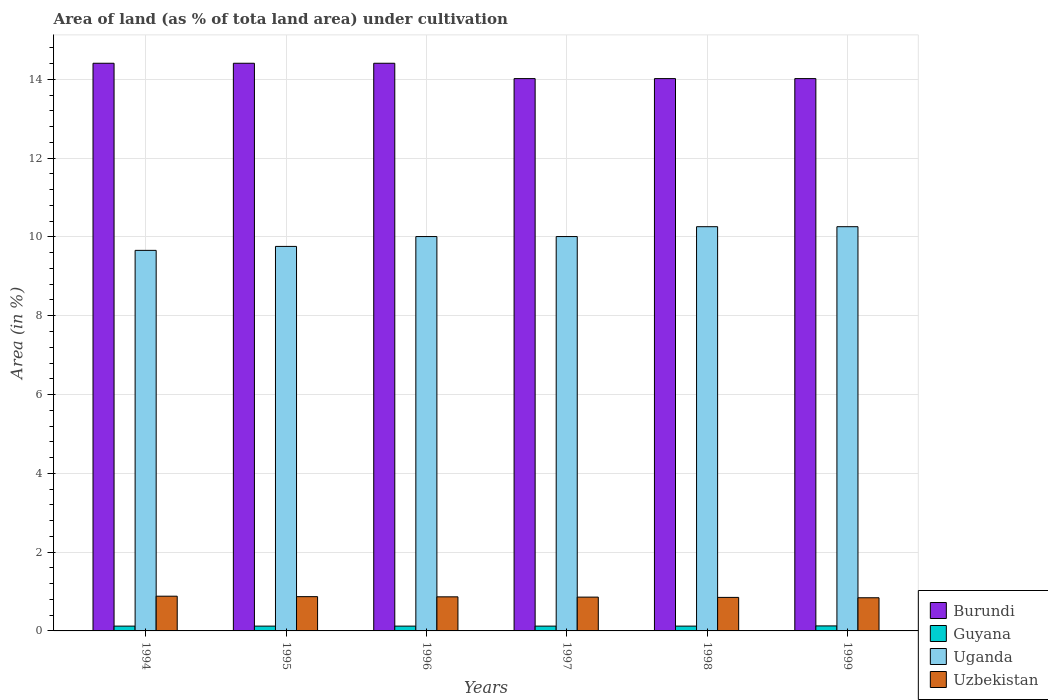Are the number of bars per tick equal to the number of legend labels?
Ensure brevity in your answer.  Yes. How many bars are there on the 4th tick from the left?
Provide a succinct answer. 4. What is the label of the 6th group of bars from the left?
Offer a very short reply. 1999. In how many cases, is the number of bars for a given year not equal to the number of legend labels?
Provide a short and direct response. 0. What is the percentage of land under cultivation in Guyana in 1994?
Make the answer very short. 0.12. Across all years, what is the maximum percentage of land under cultivation in Uganda?
Provide a succinct answer. 10.26. Across all years, what is the minimum percentage of land under cultivation in Burundi?
Offer a terse response. 14.02. In which year was the percentage of land under cultivation in Burundi maximum?
Offer a terse response. 1994. What is the total percentage of land under cultivation in Uzbekistan in the graph?
Keep it short and to the point. 5.17. What is the difference between the percentage of land under cultivation in Uzbekistan in 1997 and that in 1999?
Provide a succinct answer. 0.02. What is the difference between the percentage of land under cultivation in Uganda in 1994 and the percentage of land under cultivation in Guyana in 1995?
Your answer should be compact. 9.54. What is the average percentage of land under cultivation in Guyana per year?
Your response must be concise. 0.12. In the year 1998, what is the difference between the percentage of land under cultivation in Uzbekistan and percentage of land under cultivation in Guyana?
Your answer should be compact. 0.73. In how many years, is the percentage of land under cultivation in Uganda greater than 12 %?
Keep it short and to the point. 0. What is the ratio of the percentage of land under cultivation in Uzbekistan in 1997 to that in 1999?
Provide a short and direct response. 1.02. What is the difference between the highest and the lowest percentage of land under cultivation in Guyana?
Ensure brevity in your answer.  0.01. Is the sum of the percentage of land under cultivation in Uganda in 1995 and 1997 greater than the maximum percentage of land under cultivation in Burundi across all years?
Your answer should be compact. Yes. What does the 1st bar from the left in 1999 represents?
Keep it short and to the point. Burundi. What does the 2nd bar from the right in 1998 represents?
Keep it short and to the point. Uganda. Are all the bars in the graph horizontal?
Your answer should be very brief. No. How many years are there in the graph?
Keep it short and to the point. 6. Are the values on the major ticks of Y-axis written in scientific E-notation?
Provide a succinct answer. No. Does the graph contain any zero values?
Offer a very short reply. No. How are the legend labels stacked?
Provide a succinct answer. Vertical. What is the title of the graph?
Ensure brevity in your answer.  Area of land (as % of tota land area) under cultivation. Does "Canada" appear as one of the legend labels in the graph?
Offer a very short reply. No. What is the label or title of the Y-axis?
Provide a short and direct response. Area (in %). What is the Area (in %) of Burundi in 1994?
Make the answer very short. 14.41. What is the Area (in %) in Guyana in 1994?
Ensure brevity in your answer.  0.12. What is the Area (in %) in Uganda in 1994?
Keep it short and to the point. 9.66. What is the Area (in %) of Uzbekistan in 1994?
Offer a very short reply. 0.88. What is the Area (in %) in Burundi in 1995?
Ensure brevity in your answer.  14.41. What is the Area (in %) in Guyana in 1995?
Give a very brief answer. 0.12. What is the Area (in %) in Uganda in 1995?
Keep it short and to the point. 9.76. What is the Area (in %) of Uzbekistan in 1995?
Make the answer very short. 0.87. What is the Area (in %) in Burundi in 1996?
Your answer should be very brief. 14.41. What is the Area (in %) of Guyana in 1996?
Ensure brevity in your answer.  0.12. What is the Area (in %) of Uganda in 1996?
Your answer should be compact. 10.01. What is the Area (in %) in Uzbekistan in 1996?
Provide a short and direct response. 0.87. What is the Area (in %) in Burundi in 1997?
Ensure brevity in your answer.  14.02. What is the Area (in %) of Guyana in 1997?
Your answer should be compact. 0.12. What is the Area (in %) of Uganda in 1997?
Your answer should be compact. 10.01. What is the Area (in %) of Uzbekistan in 1997?
Offer a very short reply. 0.86. What is the Area (in %) of Burundi in 1998?
Your answer should be compact. 14.02. What is the Area (in %) in Guyana in 1998?
Ensure brevity in your answer.  0.12. What is the Area (in %) in Uganda in 1998?
Offer a terse response. 10.26. What is the Area (in %) in Uzbekistan in 1998?
Your answer should be compact. 0.85. What is the Area (in %) of Burundi in 1999?
Offer a very short reply. 14.02. What is the Area (in %) in Guyana in 1999?
Give a very brief answer. 0.13. What is the Area (in %) of Uganda in 1999?
Offer a very short reply. 10.26. What is the Area (in %) of Uzbekistan in 1999?
Keep it short and to the point. 0.84. Across all years, what is the maximum Area (in %) of Burundi?
Provide a succinct answer. 14.41. Across all years, what is the maximum Area (in %) of Guyana?
Your answer should be very brief. 0.13. Across all years, what is the maximum Area (in %) of Uganda?
Give a very brief answer. 10.26. Across all years, what is the maximum Area (in %) of Uzbekistan?
Your answer should be very brief. 0.88. Across all years, what is the minimum Area (in %) of Burundi?
Offer a very short reply. 14.02. Across all years, what is the minimum Area (in %) of Guyana?
Provide a succinct answer. 0.12. Across all years, what is the minimum Area (in %) in Uganda?
Your response must be concise. 9.66. Across all years, what is the minimum Area (in %) in Uzbekistan?
Provide a succinct answer. 0.84. What is the total Area (in %) in Burundi in the graph?
Keep it short and to the point. 85.28. What is the total Area (in %) in Guyana in the graph?
Offer a terse response. 0.74. What is the total Area (in %) of Uganda in the graph?
Provide a succinct answer. 59.96. What is the total Area (in %) in Uzbekistan in the graph?
Offer a terse response. 5.17. What is the difference between the Area (in %) of Guyana in 1994 and that in 1995?
Give a very brief answer. 0. What is the difference between the Area (in %) in Uganda in 1994 and that in 1995?
Keep it short and to the point. -0.1. What is the difference between the Area (in %) of Uzbekistan in 1994 and that in 1995?
Offer a very short reply. 0.01. What is the difference between the Area (in %) in Burundi in 1994 and that in 1996?
Offer a terse response. 0. What is the difference between the Area (in %) of Guyana in 1994 and that in 1996?
Provide a short and direct response. 0. What is the difference between the Area (in %) of Uganda in 1994 and that in 1996?
Your answer should be very brief. -0.35. What is the difference between the Area (in %) of Uzbekistan in 1994 and that in 1996?
Provide a short and direct response. 0.02. What is the difference between the Area (in %) in Burundi in 1994 and that in 1997?
Your answer should be very brief. 0.39. What is the difference between the Area (in %) in Guyana in 1994 and that in 1997?
Give a very brief answer. 0. What is the difference between the Area (in %) of Uganda in 1994 and that in 1997?
Your answer should be very brief. -0.35. What is the difference between the Area (in %) of Uzbekistan in 1994 and that in 1997?
Your answer should be compact. 0.02. What is the difference between the Area (in %) in Burundi in 1994 and that in 1998?
Give a very brief answer. 0.39. What is the difference between the Area (in %) of Uganda in 1994 and that in 1998?
Keep it short and to the point. -0.6. What is the difference between the Area (in %) of Uzbekistan in 1994 and that in 1998?
Your answer should be compact. 0.03. What is the difference between the Area (in %) in Burundi in 1994 and that in 1999?
Your answer should be very brief. 0.39. What is the difference between the Area (in %) of Guyana in 1994 and that in 1999?
Make the answer very short. -0.01. What is the difference between the Area (in %) in Uganda in 1994 and that in 1999?
Your answer should be compact. -0.6. What is the difference between the Area (in %) in Uzbekistan in 1994 and that in 1999?
Keep it short and to the point. 0.04. What is the difference between the Area (in %) in Burundi in 1995 and that in 1996?
Your response must be concise. 0. What is the difference between the Area (in %) of Uganda in 1995 and that in 1996?
Keep it short and to the point. -0.25. What is the difference between the Area (in %) in Uzbekistan in 1995 and that in 1996?
Your answer should be compact. 0. What is the difference between the Area (in %) of Burundi in 1995 and that in 1997?
Provide a succinct answer. 0.39. What is the difference between the Area (in %) in Guyana in 1995 and that in 1997?
Give a very brief answer. 0. What is the difference between the Area (in %) of Uganda in 1995 and that in 1997?
Provide a succinct answer. -0.25. What is the difference between the Area (in %) in Uzbekistan in 1995 and that in 1997?
Provide a short and direct response. 0.01. What is the difference between the Area (in %) in Burundi in 1995 and that in 1998?
Ensure brevity in your answer.  0.39. What is the difference between the Area (in %) in Uganda in 1995 and that in 1998?
Make the answer very short. -0.5. What is the difference between the Area (in %) of Uzbekistan in 1995 and that in 1998?
Your answer should be very brief. 0.02. What is the difference between the Area (in %) in Burundi in 1995 and that in 1999?
Offer a very short reply. 0.39. What is the difference between the Area (in %) of Guyana in 1995 and that in 1999?
Your response must be concise. -0.01. What is the difference between the Area (in %) in Uganda in 1995 and that in 1999?
Keep it short and to the point. -0.5. What is the difference between the Area (in %) in Uzbekistan in 1995 and that in 1999?
Make the answer very short. 0.03. What is the difference between the Area (in %) of Burundi in 1996 and that in 1997?
Ensure brevity in your answer.  0.39. What is the difference between the Area (in %) in Uganda in 1996 and that in 1997?
Offer a very short reply. 0. What is the difference between the Area (in %) of Uzbekistan in 1996 and that in 1997?
Ensure brevity in your answer.  0.01. What is the difference between the Area (in %) in Burundi in 1996 and that in 1998?
Provide a succinct answer. 0.39. What is the difference between the Area (in %) in Guyana in 1996 and that in 1998?
Your answer should be compact. 0. What is the difference between the Area (in %) in Uganda in 1996 and that in 1998?
Ensure brevity in your answer.  -0.25. What is the difference between the Area (in %) of Uzbekistan in 1996 and that in 1998?
Offer a terse response. 0.01. What is the difference between the Area (in %) of Burundi in 1996 and that in 1999?
Offer a very short reply. 0.39. What is the difference between the Area (in %) in Guyana in 1996 and that in 1999?
Offer a terse response. -0.01. What is the difference between the Area (in %) of Uganda in 1996 and that in 1999?
Make the answer very short. -0.25. What is the difference between the Area (in %) of Uzbekistan in 1996 and that in 1999?
Offer a terse response. 0.02. What is the difference between the Area (in %) in Guyana in 1997 and that in 1998?
Give a very brief answer. 0. What is the difference between the Area (in %) of Uganda in 1997 and that in 1998?
Your answer should be compact. -0.25. What is the difference between the Area (in %) of Uzbekistan in 1997 and that in 1998?
Ensure brevity in your answer.  0.01. What is the difference between the Area (in %) of Burundi in 1997 and that in 1999?
Make the answer very short. 0. What is the difference between the Area (in %) in Guyana in 1997 and that in 1999?
Provide a short and direct response. -0.01. What is the difference between the Area (in %) in Uganda in 1997 and that in 1999?
Your answer should be very brief. -0.25. What is the difference between the Area (in %) in Uzbekistan in 1997 and that in 1999?
Ensure brevity in your answer.  0.02. What is the difference between the Area (in %) of Guyana in 1998 and that in 1999?
Make the answer very short. -0.01. What is the difference between the Area (in %) of Uzbekistan in 1998 and that in 1999?
Offer a very short reply. 0.01. What is the difference between the Area (in %) of Burundi in 1994 and the Area (in %) of Guyana in 1995?
Give a very brief answer. 14.29. What is the difference between the Area (in %) in Burundi in 1994 and the Area (in %) in Uganda in 1995?
Provide a succinct answer. 4.65. What is the difference between the Area (in %) in Burundi in 1994 and the Area (in %) in Uzbekistan in 1995?
Offer a terse response. 13.54. What is the difference between the Area (in %) of Guyana in 1994 and the Area (in %) of Uganda in 1995?
Keep it short and to the point. -9.64. What is the difference between the Area (in %) in Guyana in 1994 and the Area (in %) in Uzbekistan in 1995?
Give a very brief answer. -0.75. What is the difference between the Area (in %) in Uganda in 1994 and the Area (in %) in Uzbekistan in 1995?
Keep it short and to the point. 8.79. What is the difference between the Area (in %) of Burundi in 1994 and the Area (in %) of Guyana in 1996?
Provide a succinct answer. 14.29. What is the difference between the Area (in %) of Burundi in 1994 and the Area (in %) of Uganda in 1996?
Provide a succinct answer. 4.4. What is the difference between the Area (in %) in Burundi in 1994 and the Area (in %) in Uzbekistan in 1996?
Give a very brief answer. 13.54. What is the difference between the Area (in %) of Guyana in 1994 and the Area (in %) of Uganda in 1996?
Ensure brevity in your answer.  -9.89. What is the difference between the Area (in %) in Guyana in 1994 and the Area (in %) in Uzbekistan in 1996?
Offer a very short reply. -0.74. What is the difference between the Area (in %) of Uganda in 1994 and the Area (in %) of Uzbekistan in 1996?
Give a very brief answer. 8.79. What is the difference between the Area (in %) of Burundi in 1994 and the Area (in %) of Guyana in 1997?
Your answer should be compact. 14.29. What is the difference between the Area (in %) in Burundi in 1994 and the Area (in %) in Uganda in 1997?
Your answer should be very brief. 4.4. What is the difference between the Area (in %) of Burundi in 1994 and the Area (in %) of Uzbekistan in 1997?
Provide a short and direct response. 13.55. What is the difference between the Area (in %) of Guyana in 1994 and the Area (in %) of Uganda in 1997?
Make the answer very short. -9.89. What is the difference between the Area (in %) of Guyana in 1994 and the Area (in %) of Uzbekistan in 1997?
Provide a succinct answer. -0.74. What is the difference between the Area (in %) of Uganda in 1994 and the Area (in %) of Uzbekistan in 1997?
Your answer should be compact. 8.8. What is the difference between the Area (in %) of Burundi in 1994 and the Area (in %) of Guyana in 1998?
Give a very brief answer. 14.29. What is the difference between the Area (in %) in Burundi in 1994 and the Area (in %) in Uganda in 1998?
Keep it short and to the point. 4.15. What is the difference between the Area (in %) in Burundi in 1994 and the Area (in %) in Uzbekistan in 1998?
Your answer should be very brief. 13.56. What is the difference between the Area (in %) of Guyana in 1994 and the Area (in %) of Uganda in 1998?
Ensure brevity in your answer.  -10.14. What is the difference between the Area (in %) in Guyana in 1994 and the Area (in %) in Uzbekistan in 1998?
Your response must be concise. -0.73. What is the difference between the Area (in %) in Uganda in 1994 and the Area (in %) in Uzbekistan in 1998?
Provide a succinct answer. 8.81. What is the difference between the Area (in %) in Burundi in 1994 and the Area (in %) in Guyana in 1999?
Your response must be concise. 14.28. What is the difference between the Area (in %) of Burundi in 1994 and the Area (in %) of Uganda in 1999?
Give a very brief answer. 4.15. What is the difference between the Area (in %) in Burundi in 1994 and the Area (in %) in Uzbekistan in 1999?
Provide a short and direct response. 13.57. What is the difference between the Area (in %) in Guyana in 1994 and the Area (in %) in Uganda in 1999?
Provide a short and direct response. -10.14. What is the difference between the Area (in %) in Guyana in 1994 and the Area (in %) in Uzbekistan in 1999?
Keep it short and to the point. -0.72. What is the difference between the Area (in %) in Uganda in 1994 and the Area (in %) in Uzbekistan in 1999?
Give a very brief answer. 8.82. What is the difference between the Area (in %) in Burundi in 1995 and the Area (in %) in Guyana in 1996?
Ensure brevity in your answer.  14.29. What is the difference between the Area (in %) of Burundi in 1995 and the Area (in %) of Uganda in 1996?
Ensure brevity in your answer.  4.4. What is the difference between the Area (in %) in Burundi in 1995 and the Area (in %) in Uzbekistan in 1996?
Offer a very short reply. 13.54. What is the difference between the Area (in %) in Guyana in 1995 and the Area (in %) in Uganda in 1996?
Your answer should be compact. -9.89. What is the difference between the Area (in %) of Guyana in 1995 and the Area (in %) of Uzbekistan in 1996?
Offer a very short reply. -0.74. What is the difference between the Area (in %) in Uganda in 1995 and the Area (in %) in Uzbekistan in 1996?
Your response must be concise. 8.89. What is the difference between the Area (in %) in Burundi in 1995 and the Area (in %) in Guyana in 1997?
Give a very brief answer. 14.29. What is the difference between the Area (in %) in Burundi in 1995 and the Area (in %) in Uganda in 1997?
Your answer should be very brief. 4.4. What is the difference between the Area (in %) of Burundi in 1995 and the Area (in %) of Uzbekistan in 1997?
Offer a very short reply. 13.55. What is the difference between the Area (in %) of Guyana in 1995 and the Area (in %) of Uganda in 1997?
Your answer should be very brief. -9.89. What is the difference between the Area (in %) of Guyana in 1995 and the Area (in %) of Uzbekistan in 1997?
Offer a very short reply. -0.74. What is the difference between the Area (in %) in Uganda in 1995 and the Area (in %) in Uzbekistan in 1997?
Your response must be concise. 8.9. What is the difference between the Area (in %) in Burundi in 1995 and the Area (in %) in Guyana in 1998?
Provide a succinct answer. 14.29. What is the difference between the Area (in %) of Burundi in 1995 and the Area (in %) of Uganda in 1998?
Provide a succinct answer. 4.15. What is the difference between the Area (in %) in Burundi in 1995 and the Area (in %) in Uzbekistan in 1998?
Give a very brief answer. 13.56. What is the difference between the Area (in %) of Guyana in 1995 and the Area (in %) of Uganda in 1998?
Provide a short and direct response. -10.14. What is the difference between the Area (in %) of Guyana in 1995 and the Area (in %) of Uzbekistan in 1998?
Your response must be concise. -0.73. What is the difference between the Area (in %) in Uganda in 1995 and the Area (in %) in Uzbekistan in 1998?
Your answer should be very brief. 8.91. What is the difference between the Area (in %) of Burundi in 1995 and the Area (in %) of Guyana in 1999?
Your answer should be very brief. 14.28. What is the difference between the Area (in %) of Burundi in 1995 and the Area (in %) of Uganda in 1999?
Your answer should be very brief. 4.15. What is the difference between the Area (in %) in Burundi in 1995 and the Area (in %) in Uzbekistan in 1999?
Make the answer very short. 13.57. What is the difference between the Area (in %) of Guyana in 1995 and the Area (in %) of Uganda in 1999?
Give a very brief answer. -10.14. What is the difference between the Area (in %) in Guyana in 1995 and the Area (in %) in Uzbekistan in 1999?
Provide a succinct answer. -0.72. What is the difference between the Area (in %) in Uganda in 1995 and the Area (in %) in Uzbekistan in 1999?
Provide a succinct answer. 8.92. What is the difference between the Area (in %) of Burundi in 1996 and the Area (in %) of Guyana in 1997?
Offer a very short reply. 14.29. What is the difference between the Area (in %) of Burundi in 1996 and the Area (in %) of Uganda in 1997?
Your answer should be compact. 4.4. What is the difference between the Area (in %) in Burundi in 1996 and the Area (in %) in Uzbekistan in 1997?
Make the answer very short. 13.55. What is the difference between the Area (in %) of Guyana in 1996 and the Area (in %) of Uganda in 1997?
Provide a succinct answer. -9.89. What is the difference between the Area (in %) of Guyana in 1996 and the Area (in %) of Uzbekistan in 1997?
Provide a succinct answer. -0.74. What is the difference between the Area (in %) in Uganda in 1996 and the Area (in %) in Uzbekistan in 1997?
Give a very brief answer. 9.15. What is the difference between the Area (in %) in Burundi in 1996 and the Area (in %) in Guyana in 1998?
Provide a short and direct response. 14.29. What is the difference between the Area (in %) of Burundi in 1996 and the Area (in %) of Uganda in 1998?
Ensure brevity in your answer.  4.15. What is the difference between the Area (in %) of Burundi in 1996 and the Area (in %) of Uzbekistan in 1998?
Keep it short and to the point. 13.56. What is the difference between the Area (in %) in Guyana in 1996 and the Area (in %) in Uganda in 1998?
Provide a succinct answer. -10.14. What is the difference between the Area (in %) of Guyana in 1996 and the Area (in %) of Uzbekistan in 1998?
Your answer should be very brief. -0.73. What is the difference between the Area (in %) of Uganda in 1996 and the Area (in %) of Uzbekistan in 1998?
Make the answer very short. 9.16. What is the difference between the Area (in %) of Burundi in 1996 and the Area (in %) of Guyana in 1999?
Keep it short and to the point. 14.28. What is the difference between the Area (in %) in Burundi in 1996 and the Area (in %) in Uganda in 1999?
Give a very brief answer. 4.15. What is the difference between the Area (in %) in Burundi in 1996 and the Area (in %) in Uzbekistan in 1999?
Your response must be concise. 13.57. What is the difference between the Area (in %) of Guyana in 1996 and the Area (in %) of Uganda in 1999?
Ensure brevity in your answer.  -10.14. What is the difference between the Area (in %) of Guyana in 1996 and the Area (in %) of Uzbekistan in 1999?
Your answer should be compact. -0.72. What is the difference between the Area (in %) in Uganda in 1996 and the Area (in %) in Uzbekistan in 1999?
Offer a terse response. 9.17. What is the difference between the Area (in %) of Burundi in 1997 and the Area (in %) of Guyana in 1998?
Your answer should be very brief. 13.9. What is the difference between the Area (in %) in Burundi in 1997 and the Area (in %) in Uganda in 1998?
Your response must be concise. 3.76. What is the difference between the Area (in %) of Burundi in 1997 and the Area (in %) of Uzbekistan in 1998?
Offer a very short reply. 13.17. What is the difference between the Area (in %) in Guyana in 1997 and the Area (in %) in Uganda in 1998?
Make the answer very short. -10.14. What is the difference between the Area (in %) in Guyana in 1997 and the Area (in %) in Uzbekistan in 1998?
Your response must be concise. -0.73. What is the difference between the Area (in %) of Uganda in 1997 and the Area (in %) of Uzbekistan in 1998?
Provide a succinct answer. 9.16. What is the difference between the Area (in %) in Burundi in 1997 and the Area (in %) in Guyana in 1999?
Make the answer very short. 13.89. What is the difference between the Area (in %) in Burundi in 1997 and the Area (in %) in Uganda in 1999?
Offer a very short reply. 3.76. What is the difference between the Area (in %) of Burundi in 1997 and the Area (in %) of Uzbekistan in 1999?
Give a very brief answer. 13.18. What is the difference between the Area (in %) of Guyana in 1997 and the Area (in %) of Uganda in 1999?
Your response must be concise. -10.14. What is the difference between the Area (in %) of Guyana in 1997 and the Area (in %) of Uzbekistan in 1999?
Keep it short and to the point. -0.72. What is the difference between the Area (in %) of Uganda in 1997 and the Area (in %) of Uzbekistan in 1999?
Provide a short and direct response. 9.17. What is the difference between the Area (in %) in Burundi in 1998 and the Area (in %) in Guyana in 1999?
Make the answer very short. 13.89. What is the difference between the Area (in %) in Burundi in 1998 and the Area (in %) in Uganda in 1999?
Your answer should be compact. 3.76. What is the difference between the Area (in %) in Burundi in 1998 and the Area (in %) in Uzbekistan in 1999?
Your response must be concise. 13.18. What is the difference between the Area (in %) of Guyana in 1998 and the Area (in %) of Uganda in 1999?
Keep it short and to the point. -10.14. What is the difference between the Area (in %) of Guyana in 1998 and the Area (in %) of Uzbekistan in 1999?
Your response must be concise. -0.72. What is the difference between the Area (in %) in Uganda in 1998 and the Area (in %) in Uzbekistan in 1999?
Your response must be concise. 9.42. What is the average Area (in %) in Burundi per year?
Make the answer very short. 14.21. What is the average Area (in %) in Guyana per year?
Provide a short and direct response. 0.12. What is the average Area (in %) in Uganda per year?
Offer a terse response. 9.99. What is the average Area (in %) of Uzbekistan per year?
Give a very brief answer. 0.86. In the year 1994, what is the difference between the Area (in %) in Burundi and Area (in %) in Guyana?
Keep it short and to the point. 14.29. In the year 1994, what is the difference between the Area (in %) of Burundi and Area (in %) of Uganda?
Your answer should be compact. 4.75. In the year 1994, what is the difference between the Area (in %) of Burundi and Area (in %) of Uzbekistan?
Keep it short and to the point. 13.53. In the year 1994, what is the difference between the Area (in %) in Guyana and Area (in %) in Uganda?
Ensure brevity in your answer.  -9.54. In the year 1994, what is the difference between the Area (in %) of Guyana and Area (in %) of Uzbekistan?
Keep it short and to the point. -0.76. In the year 1994, what is the difference between the Area (in %) in Uganda and Area (in %) in Uzbekistan?
Your answer should be very brief. 8.78. In the year 1995, what is the difference between the Area (in %) in Burundi and Area (in %) in Guyana?
Ensure brevity in your answer.  14.29. In the year 1995, what is the difference between the Area (in %) of Burundi and Area (in %) of Uganda?
Your answer should be compact. 4.65. In the year 1995, what is the difference between the Area (in %) of Burundi and Area (in %) of Uzbekistan?
Keep it short and to the point. 13.54. In the year 1995, what is the difference between the Area (in %) of Guyana and Area (in %) of Uganda?
Ensure brevity in your answer.  -9.64. In the year 1995, what is the difference between the Area (in %) of Guyana and Area (in %) of Uzbekistan?
Your answer should be compact. -0.75. In the year 1995, what is the difference between the Area (in %) of Uganda and Area (in %) of Uzbekistan?
Keep it short and to the point. 8.89. In the year 1996, what is the difference between the Area (in %) of Burundi and Area (in %) of Guyana?
Your response must be concise. 14.29. In the year 1996, what is the difference between the Area (in %) of Burundi and Area (in %) of Uganda?
Offer a terse response. 4.4. In the year 1996, what is the difference between the Area (in %) in Burundi and Area (in %) in Uzbekistan?
Your response must be concise. 13.54. In the year 1996, what is the difference between the Area (in %) of Guyana and Area (in %) of Uganda?
Provide a short and direct response. -9.89. In the year 1996, what is the difference between the Area (in %) of Guyana and Area (in %) of Uzbekistan?
Keep it short and to the point. -0.74. In the year 1996, what is the difference between the Area (in %) in Uganda and Area (in %) in Uzbekistan?
Offer a terse response. 9.14. In the year 1997, what is the difference between the Area (in %) in Burundi and Area (in %) in Guyana?
Give a very brief answer. 13.9. In the year 1997, what is the difference between the Area (in %) of Burundi and Area (in %) of Uganda?
Offer a very short reply. 4.01. In the year 1997, what is the difference between the Area (in %) in Burundi and Area (in %) in Uzbekistan?
Your answer should be compact. 13.16. In the year 1997, what is the difference between the Area (in %) of Guyana and Area (in %) of Uganda?
Keep it short and to the point. -9.89. In the year 1997, what is the difference between the Area (in %) of Guyana and Area (in %) of Uzbekistan?
Provide a short and direct response. -0.74. In the year 1997, what is the difference between the Area (in %) of Uganda and Area (in %) of Uzbekistan?
Ensure brevity in your answer.  9.15. In the year 1998, what is the difference between the Area (in %) of Burundi and Area (in %) of Guyana?
Your answer should be very brief. 13.9. In the year 1998, what is the difference between the Area (in %) of Burundi and Area (in %) of Uganda?
Give a very brief answer. 3.76. In the year 1998, what is the difference between the Area (in %) in Burundi and Area (in %) in Uzbekistan?
Provide a short and direct response. 13.17. In the year 1998, what is the difference between the Area (in %) in Guyana and Area (in %) in Uganda?
Your response must be concise. -10.14. In the year 1998, what is the difference between the Area (in %) in Guyana and Area (in %) in Uzbekistan?
Your answer should be compact. -0.73. In the year 1998, what is the difference between the Area (in %) in Uganda and Area (in %) in Uzbekistan?
Provide a succinct answer. 9.41. In the year 1999, what is the difference between the Area (in %) in Burundi and Area (in %) in Guyana?
Provide a short and direct response. 13.89. In the year 1999, what is the difference between the Area (in %) in Burundi and Area (in %) in Uganda?
Provide a short and direct response. 3.76. In the year 1999, what is the difference between the Area (in %) of Burundi and Area (in %) of Uzbekistan?
Provide a succinct answer. 13.18. In the year 1999, what is the difference between the Area (in %) in Guyana and Area (in %) in Uganda?
Provide a short and direct response. -10.13. In the year 1999, what is the difference between the Area (in %) in Guyana and Area (in %) in Uzbekistan?
Your answer should be compact. -0.71. In the year 1999, what is the difference between the Area (in %) of Uganda and Area (in %) of Uzbekistan?
Offer a terse response. 9.42. What is the ratio of the Area (in %) in Uganda in 1994 to that in 1995?
Give a very brief answer. 0.99. What is the ratio of the Area (in %) of Uzbekistan in 1994 to that in 1995?
Provide a short and direct response. 1.01. What is the ratio of the Area (in %) of Uganda in 1994 to that in 1996?
Your answer should be very brief. 0.96. What is the ratio of the Area (in %) in Burundi in 1994 to that in 1997?
Give a very brief answer. 1.03. What is the ratio of the Area (in %) in Uzbekistan in 1994 to that in 1997?
Give a very brief answer. 1.03. What is the ratio of the Area (in %) in Burundi in 1994 to that in 1998?
Provide a short and direct response. 1.03. What is the ratio of the Area (in %) in Uganda in 1994 to that in 1998?
Make the answer very short. 0.94. What is the ratio of the Area (in %) in Uzbekistan in 1994 to that in 1998?
Give a very brief answer. 1.04. What is the ratio of the Area (in %) of Burundi in 1994 to that in 1999?
Your answer should be compact. 1.03. What is the ratio of the Area (in %) in Uganda in 1994 to that in 1999?
Provide a succinct answer. 0.94. What is the ratio of the Area (in %) of Uzbekistan in 1994 to that in 1999?
Provide a short and direct response. 1.05. What is the ratio of the Area (in %) in Guyana in 1995 to that in 1996?
Offer a very short reply. 1. What is the ratio of the Area (in %) in Uganda in 1995 to that in 1996?
Ensure brevity in your answer.  0.97. What is the ratio of the Area (in %) in Uzbekistan in 1995 to that in 1996?
Your answer should be compact. 1.01. What is the ratio of the Area (in %) of Burundi in 1995 to that in 1997?
Your answer should be compact. 1.03. What is the ratio of the Area (in %) in Guyana in 1995 to that in 1997?
Provide a succinct answer. 1. What is the ratio of the Area (in %) of Uzbekistan in 1995 to that in 1997?
Your answer should be compact. 1.01. What is the ratio of the Area (in %) of Burundi in 1995 to that in 1998?
Ensure brevity in your answer.  1.03. What is the ratio of the Area (in %) of Uganda in 1995 to that in 1998?
Your answer should be compact. 0.95. What is the ratio of the Area (in %) of Uzbekistan in 1995 to that in 1998?
Offer a terse response. 1.02. What is the ratio of the Area (in %) in Burundi in 1995 to that in 1999?
Ensure brevity in your answer.  1.03. What is the ratio of the Area (in %) of Uganda in 1995 to that in 1999?
Provide a succinct answer. 0.95. What is the ratio of the Area (in %) of Uzbekistan in 1995 to that in 1999?
Provide a succinct answer. 1.03. What is the ratio of the Area (in %) in Burundi in 1996 to that in 1997?
Provide a succinct answer. 1.03. What is the ratio of the Area (in %) of Guyana in 1996 to that in 1997?
Your answer should be compact. 1. What is the ratio of the Area (in %) in Uganda in 1996 to that in 1997?
Provide a short and direct response. 1. What is the ratio of the Area (in %) in Uzbekistan in 1996 to that in 1997?
Your answer should be compact. 1.01. What is the ratio of the Area (in %) of Burundi in 1996 to that in 1998?
Keep it short and to the point. 1.03. What is the ratio of the Area (in %) in Uganda in 1996 to that in 1998?
Ensure brevity in your answer.  0.98. What is the ratio of the Area (in %) in Uzbekistan in 1996 to that in 1998?
Provide a succinct answer. 1.02. What is the ratio of the Area (in %) of Burundi in 1996 to that in 1999?
Your answer should be compact. 1.03. What is the ratio of the Area (in %) in Guyana in 1996 to that in 1999?
Provide a short and direct response. 0.96. What is the ratio of the Area (in %) in Uganda in 1996 to that in 1999?
Give a very brief answer. 0.98. What is the ratio of the Area (in %) of Uzbekistan in 1996 to that in 1999?
Your answer should be compact. 1.03. What is the ratio of the Area (in %) of Uganda in 1997 to that in 1998?
Your response must be concise. 0.98. What is the ratio of the Area (in %) of Uzbekistan in 1997 to that in 1998?
Keep it short and to the point. 1.01. What is the ratio of the Area (in %) of Uganda in 1997 to that in 1999?
Make the answer very short. 0.98. What is the ratio of the Area (in %) in Uzbekistan in 1997 to that in 1999?
Your answer should be very brief. 1.02. What is the ratio of the Area (in %) of Uganda in 1998 to that in 1999?
Offer a very short reply. 1. What is the ratio of the Area (in %) in Uzbekistan in 1998 to that in 1999?
Your answer should be compact. 1.01. What is the difference between the highest and the second highest Area (in %) in Burundi?
Provide a succinct answer. 0. What is the difference between the highest and the second highest Area (in %) in Guyana?
Offer a terse response. 0.01. What is the difference between the highest and the second highest Area (in %) in Uzbekistan?
Your response must be concise. 0.01. What is the difference between the highest and the lowest Area (in %) of Burundi?
Keep it short and to the point. 0.39. What is the difference between the highest and the lowest Area (in %) of Guyana?
Keep it short and to the point. 0.01. What is the difference between the highest and the lowest Area (in %) of Uganda?
Your answer should be compact. 0.6. 